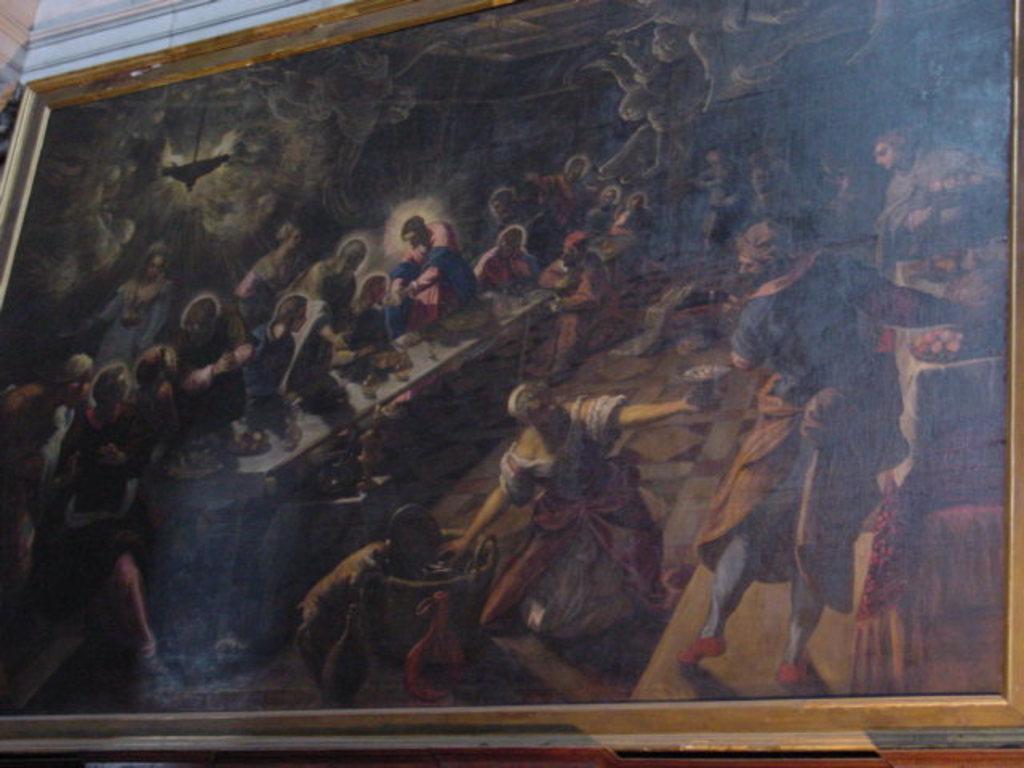Could you give a brief overview of what you see in this image? In the picture I can see frame to the wall, in which we can see some people. 